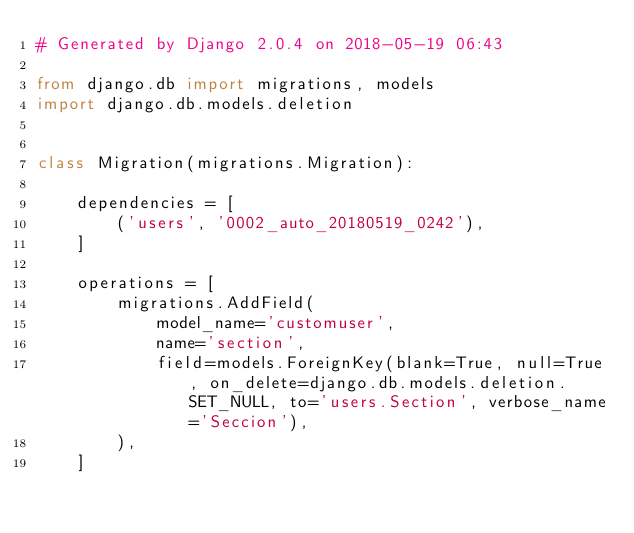<code> <loc_0><loc_0><loc_500><loc_500><_Python_># Generated by Django 2.0.4 on 2018-05-19 06:43

from django.db import migrations, models
import django.db.models.deletion


class Migration(migrations.Migration):

    dependencies = [
        ('users', '0002_auto_20180519_0242'),
    ]

    operations = [
        migrations.AddField(
            model_name='customuser',
            name='section',
            field=models.ForeignKey(blank=True, null=True, on_delete=django.db.models.deletion.SET_NULL, to='users.Section', verbose_name='Seccion'),
        ),
    ]
</code> 